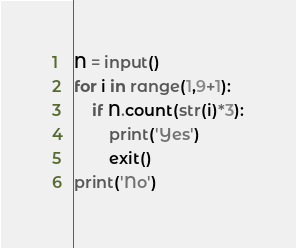Convert code to text. <code><loc_0><loc_0><loc_500><loc_500><_Python_>N = input()
for i in range(1,9+1):
    if N.count(str(i)*3):
        print('Yes')
        exit()
print('No')

</code> 